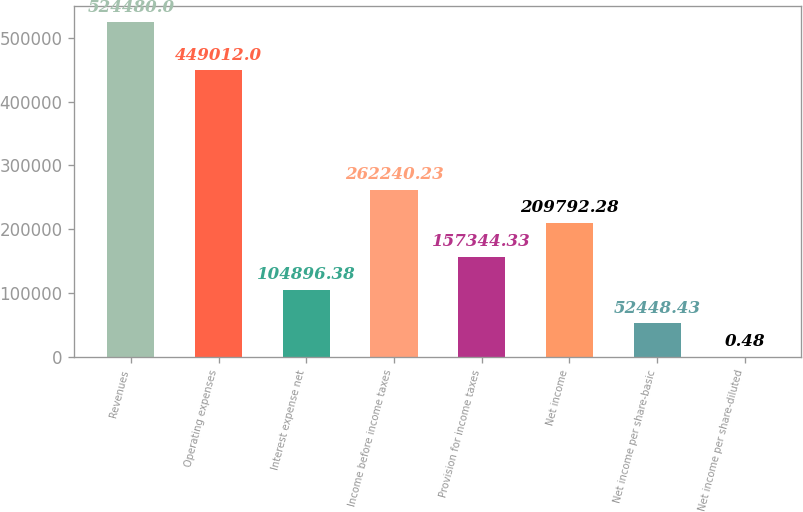Convert chart to OTSL. <chart><loc_0><loc_0><loc_500><loc_500><bar_chart><fcel>Revenues<fcel>Operating expenses<fcel>Interest expense net<fcel>Income before income taxes<fcel>Provision for income taxes<fcel>Net income<fcel>Net income per share-basic<fcel>Net income per share-diluted<nl><fcel>524480<fcel>449012<fcel>104896<fcel>262240<fcel>157344<fcel>209792<fcel>52448.4<fcel>0.48<nl></chart> 